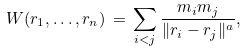Convert formula to latex. <formula><loc_0><loc_0><loc_500><loc_500>W ( { r } _ { 1 } , \dots , { r } _ { n } ) \, = \, \sum _ { i < j } \frac { m _ { i } m _ { j } } { \| { r } _ { i } - { r } _ { j } \| ^ { a } } ,</formula> 